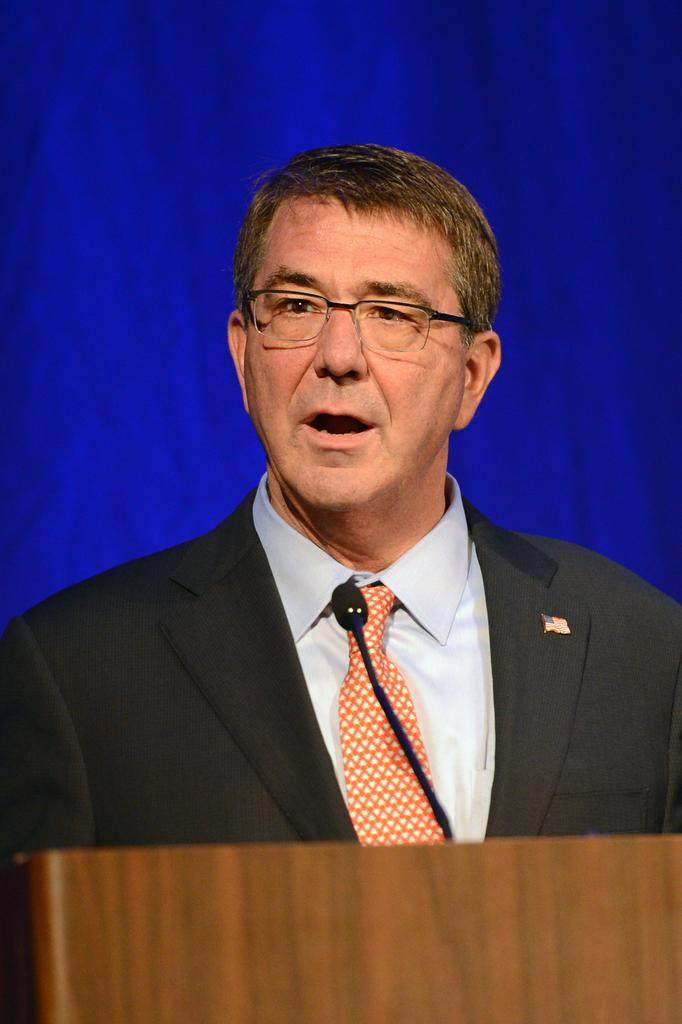What is the main subject of the image? There is a person in a suit in the center of the image. What is the person in the image doing? The person is talking. What object is present in the foreground of the image? There is a podium in the foreground of the image. What is on the podium? There is a microphone on the podium. What can be seen in the background of the image? There is a blue curtain in the background of the image. What type of rifle is the person holding in the image? There is no rifle present in the image; the person is holding a microphone on a podium. 